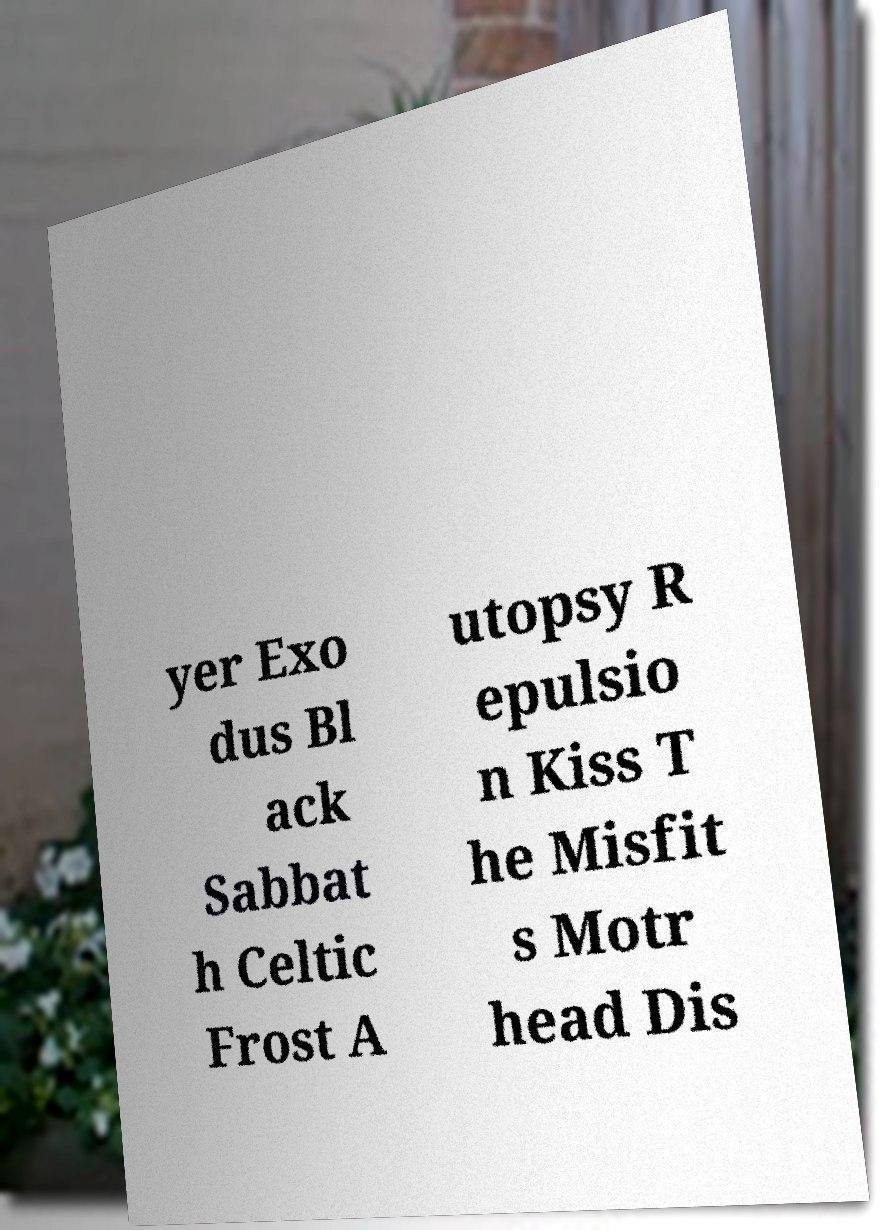Could you extract and type out the text from this image? yer Exo dus Bl ack Sabbat h Celtic Frost A utopsy R epulsio n Kiss T he Misfit s Motr head Dis 